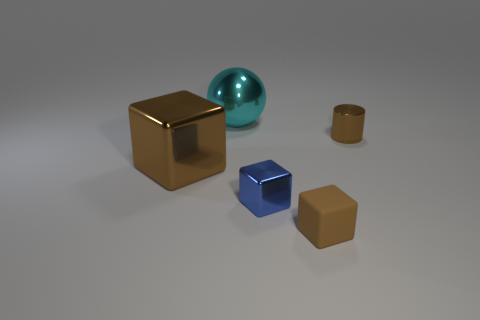There is a blue cube that is made of the same material as the small brown cylinder; what size is it?
Your response must be concise. Small. How many other brown matte objects have the same shape as the rubber object?
Give a very brief answer. 0. Is the material of the blue thing the same as the brown thing left of the cyan metallic ball?
Offer a terse response. Yes. Are there more metallic balls behind the tiny matte block than cylinders?
Offer a terse response. No. The rubber object that is the same color as the big metallic cube is what shape?
Offer a terse response. Cube. Are there any cylinders made of the same material as the sphere?
Keep it short and to the point. Yes. Does the tiny thing to the left of the small brown rubber block have the same material as the small thing behind the tiny metal block?
Offer a very short reply. Yes. Is the number of tiny matte blocks that are behind the cylinder the same as the number of big metal things on the right side of the big cyan shiny ball?
Give a very brief answer. Yes. What color is the rubber cube that is the same size as the brown shiny cylinder?
Offer a terse response. Brown. Is there a large metal object of the same color as the large metallic sphere?
Your answer should be compact. No. 